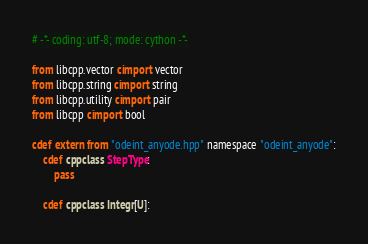Convert code to text. <code><loc_0><loc_0><loc_500><loc_500><_Cython_># -*- coding: utf-8; mode: cython -*-

from libcpp.vector cimport vector
from libcpp.string cimport string
from libcpp.utility cimport pair
from libcpp cimport bool

cdef extern from "odeint_anyode.hpp" namespace "odeint_anyode":
    cdef cppclass StepType:
        pass

    cdef cppclass Integr[U]:</code> 